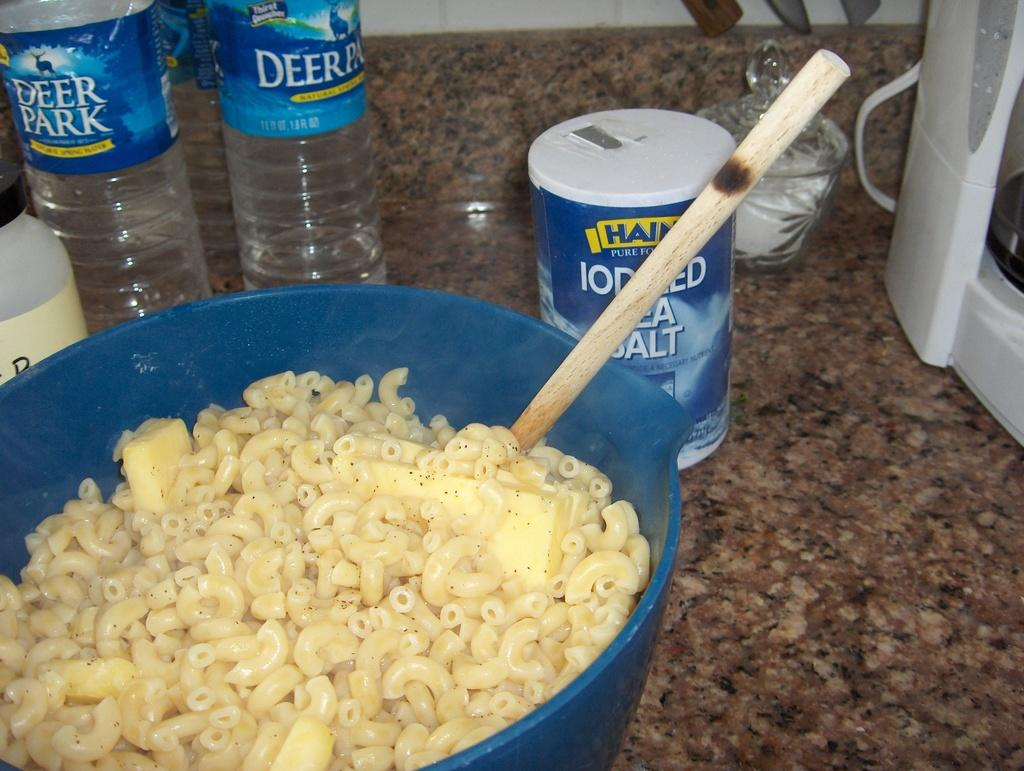What is in the bowl that is visible in the image? There is a bowl with food in the image. Where is the bowl located in the image? The bowl is placed on a table. What other items can be seen in the image besides the bowl? There is a bottle and a tin in the image. What type of protest is taking place in the image? There is no protest present in the image; it features a bowl with food, a bottle, and a tin. Can you tell me who the father is in the image? There is no reference to a father or any people in the image. 